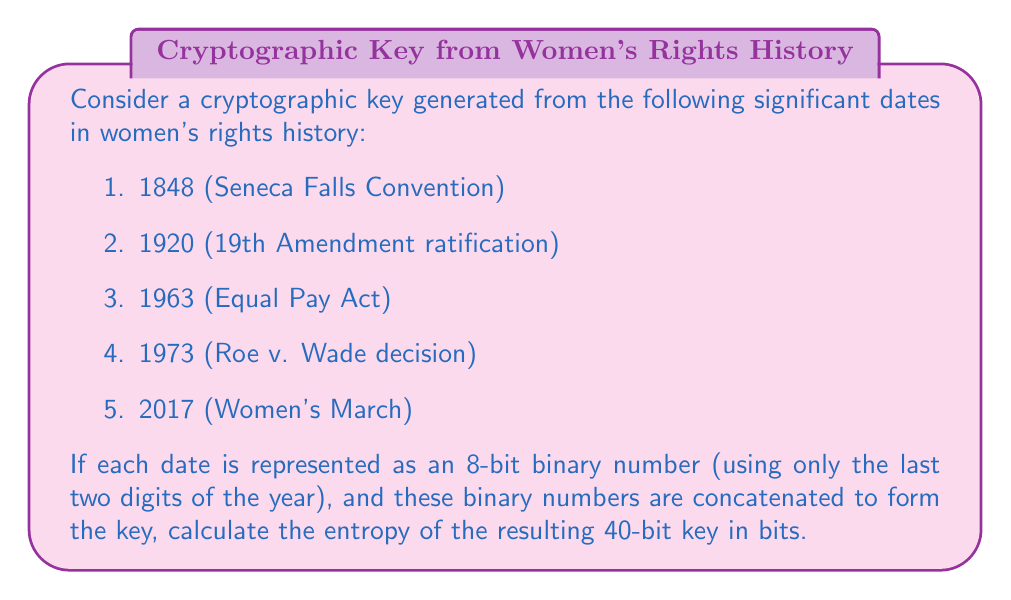What is the answer to this math problem? To calculate the entropy of the cryptographic key, we'll follow these steps:

1. Convert the last two digits of each year to 8-bit binary:
   1848 → 48 → 00110000
   1920 → 20 → 00010100
   1963 → 63 → 00111111
   1973 → 73 → 01001001
   2017 → 17 → 00010001

2. Concatenate the binary numbers:
   0011000000010100001111110100100100010001

3. To calculate the entropy, we need to determine the number of possible keys. Since we're using specific dates, not all 40-bit combinations are possible. We have 5 dates, each represented by 8 bits, so the number of possible keys is:

   $N = 2^8 \times 2^8 \times 2^8 \times 2^8 \times 2^8 = (2^8)^5 = 2^{40}$

4. The entropy (H) is calculated using the formula:

   $H = \log_2(N)$

   Where N is the number of possible keys.

5. Substituting our value for N:

   $H = \log_2(2^{40}) = 40$ bits

Therefore, the entropy of the key is 40 bits.
Answer: 40 bits 